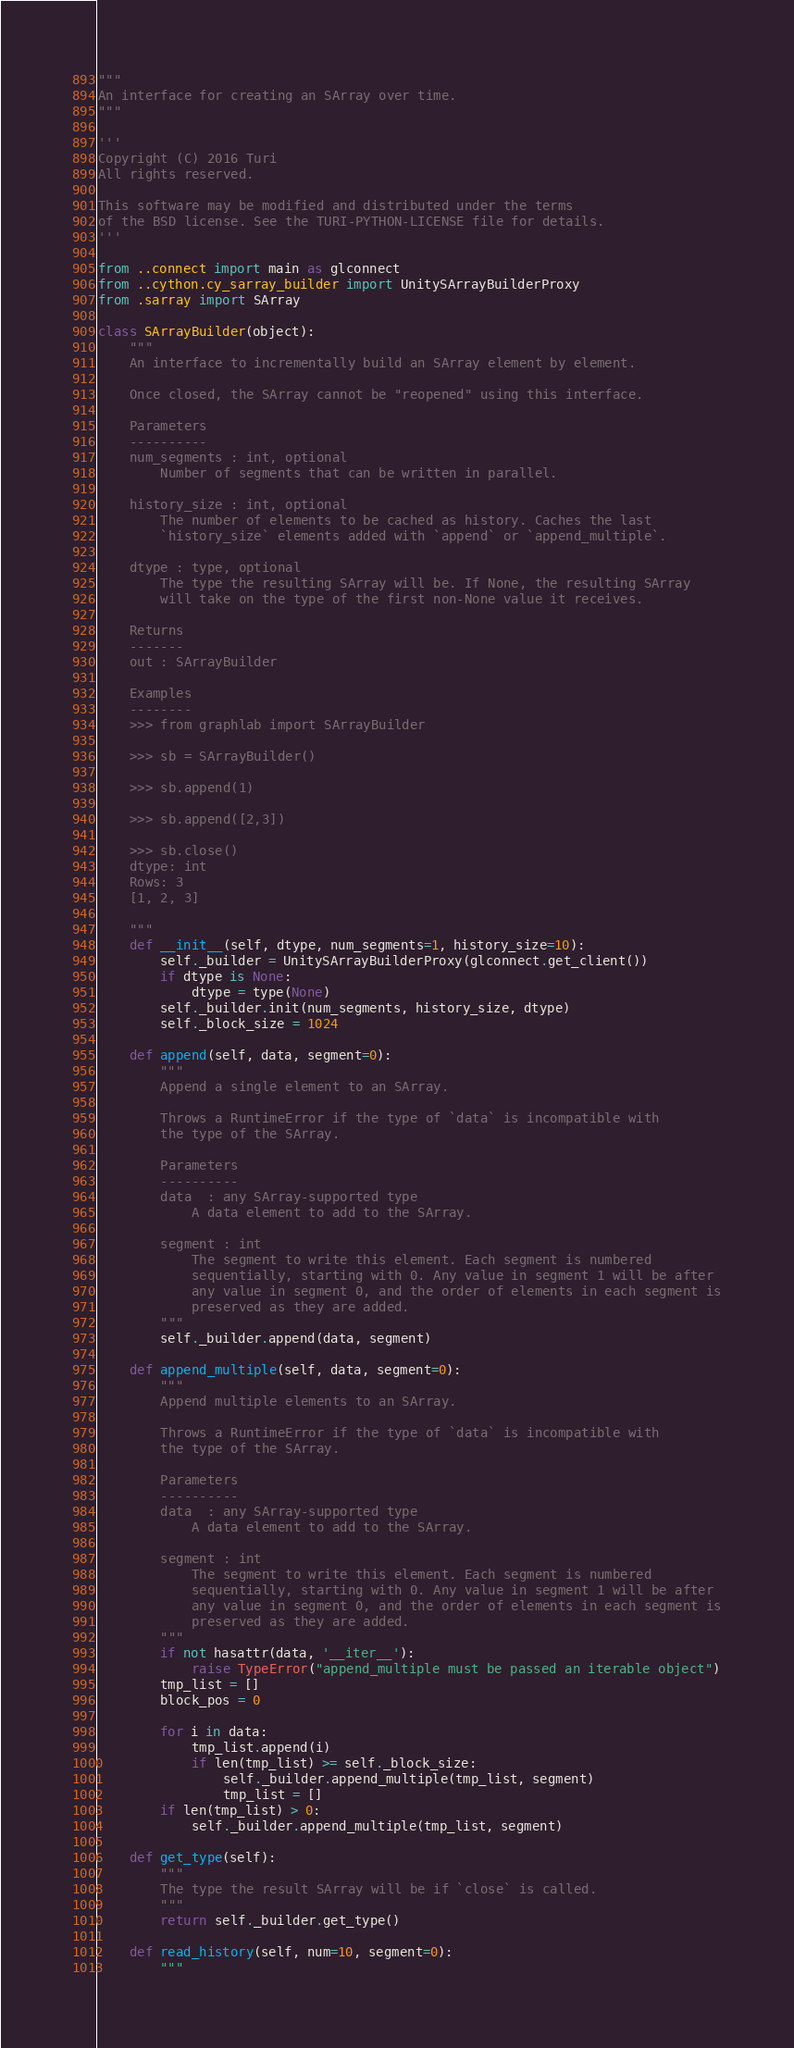Convert code to text. <code><loc_0><loc_0><loc_500><loc_500><_Python_>"""
An interface for creating an SArray over time.
"""

'''
Copyright (C) 2016 Turi
All rights reserved.

This software may be modified and distributed under the terms
of the BSD license. See the TURI-PYTHON-LICENSE file for details.
'''

from ..connect import main as glconnect
from ..cython.cy_sarray_builder import UnitySArrayBuilderProxy
from .sarray import SArray

class SArrayBuilder(object):
    """
    An interface to incrementally build an SArray element by element.

    Once closed, the SArray cannot be "reopened" using this interface.

    Parameters
    ----------
    num_segments : int, optional
        Number of segments that can be written in parallel.

    history_size : int, optional
        The number of elements to be cached as history. Caches the last
        `history_size` elements added with `append` or `append_multiple`.

    dtype : type, optional
        The type the resulting SArray will be. If None, the resulting SArray
        will take on the type of the first non-None value it receives.
        
    Returns
    -------
    out : SArrayBuilder

    Examples
    --------
    >>> from graphlab import SArrayBuilder

    >>> sb = SArrayBuilder()

    >>> sb.append(1)

    >>> sb.append([2,3])

    >>> sb.close()
    dtype: int
    Rows: 3
    [1, 2, 3]

    """
    def __init__(self, dtype, num_segments=1, history_size=10):
        self._builder = UnitySArrayBuilderProxy(glconnect.get_client())
        if dtype is None:
            dtype = type(None)
        self._builder.init(num_segments, history_size, dtype)
        self._block_size = 1024

    def append(self, data, segment=0):
        """
        Append a single element to an SArray.

        Throws a RuntimeError if the type of `data` is incompatible with
        the type of the SArray. 

        Parameters
        ----------
        data  : any SArray-supported type
            A data element to add to the SArray.

        segment : int
            The segment to write this element. Each segment is numbered
            sequentially, starting with 0. Any value in segment 1 will be after
            any value in segment 0, and the order of elements in each segment is
            preserved as they are added.
        """
        self._builder.append(data, segment)
        
    def append_multiple(self, data, segment=0):
        """
        Append multiple elements to an SArray.

        Throws a RuntimeError if the type of `data` is incompatible with
        the type of the SArray. 

        Parameters
        ----------
        data  : any SArray-supported type
            A data element to add to the SArray.

        segment : int
            The segment to write this element. Each segment is numbered
            sequentially, starting with 0. Any value in segment 1 will be after
            any value in segment 0, and the order of elements in each segment is
            preserved as they are added.
        """
        if not hasattr(data, '__iter__'):
            raise TypeError("append_multiple must be passed an iterable object")
        tmp_list = []
        block_pos = 0

        for i in data:
            tmp_list.append(i)
            if len(tmp_list) >= self._block_size:
                self._builder.append_multiple(tmp_list, segment)
                tmp_list = []
        if len(tmp_list) > 0:
            self._builder.append_multiple(tmp_list, segment)

    def get_type(self):
        """
        The type the result SArray will be if `close` is called.
        """
        return self._builder.get_type()

    def read_history(self, num=10, segment=0):
        """</code> 